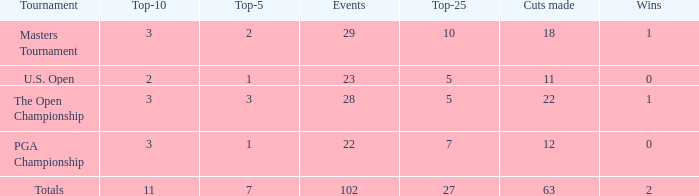How many vuts made for a player with 2 wins and under 7 top 5s? None. 